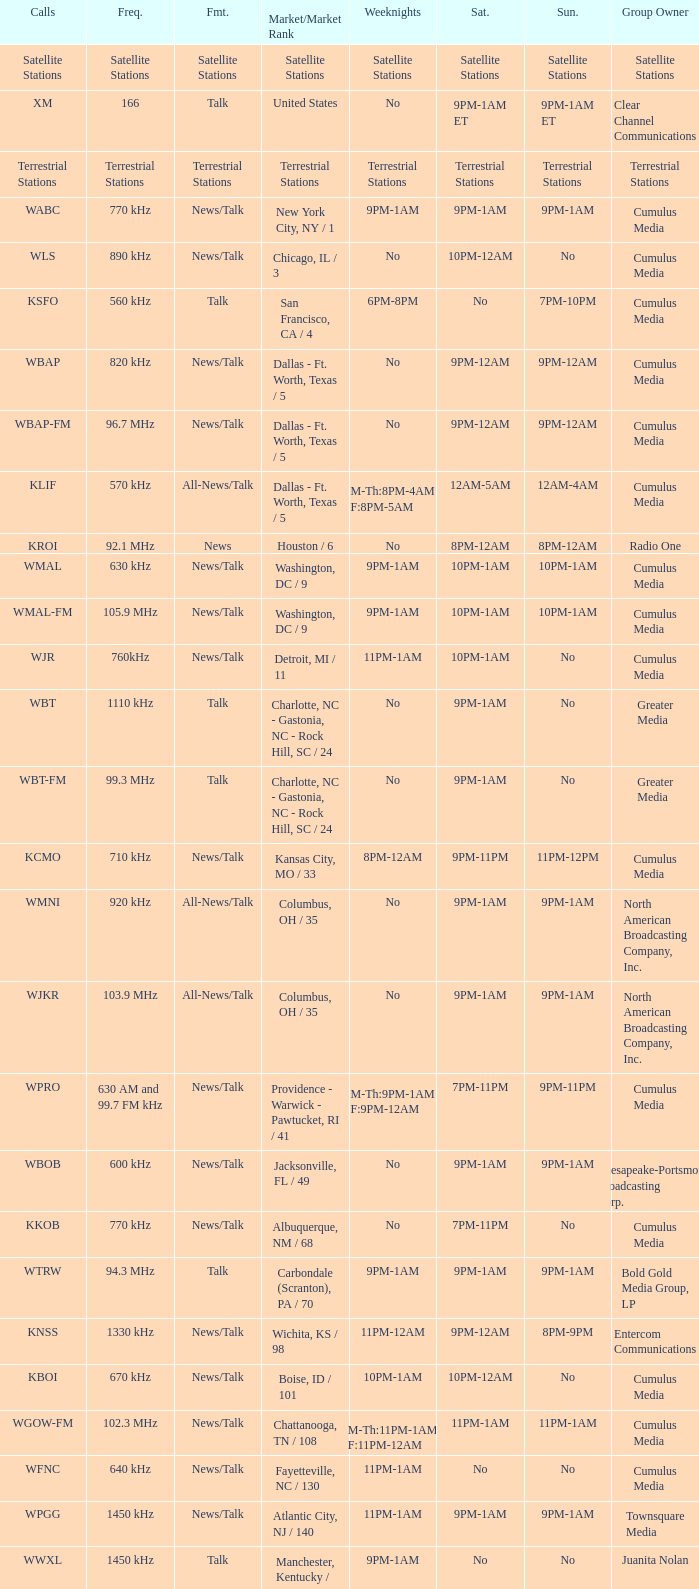What is the market for the 11pm-1am Saturday game? Chattanooga, TN / 108. Write the full table. {'header': ['Calls', 'Freq.', 'Fmt.', 'Market/Market Rank', 'Weeknights', 'Sat.', 'Sun.', 'Group Owner'], 'rows': [['Satellite Stations', 'Satellite Stations', 'Satellite Stations', 'Satellite Stations', 'Satellite Stations', 'Satellite Stations', 'Satellite Stations', 'Satellite Stations'], ['XM', '166', 'Talk', 'United States', 'No', '9PM-1AM ET', '9PM-1AM ET', 'Clear Channel Communications'], ['Terrestrial Stations', 'Terrestrial Stations', 'Terrestrial Stations', 'Terrestrial Stations', 'Terrestrial Stations', 'Terrestrial Stations', 'Terrestrial Stations', 'Terrestrial Stations'], ['WABC', '770 kHz', 'News/Talk', 'New York City, NY / 1', '9PM-1AM', '9PM-1AM', '9PM-1AM', 'Cumulus Media'], ['WLS', '890 kHz', 'News/Talk', 'Chicago, IL / 3', 'No', '10PM-12AM', 'No', 'Cumulus Media'], ['KSFO', '560 kHz', 'Talk', 'San Francisco, CA / 4', '6PM-8PM', 'No', '7PM-10PM', 'Cumulus Media'], ['WBAP', '820 kHz', 'News/Talk', 'Dallas - Ft. Worth, Texas / 5', 'No', '9PM-12AM', '9PM-12AM', 'Cumulus Media'], ['WBAP-FM', '96.7 MHz', 'News/Talk', 'Dallas - Ft. Worth, Texas / 5', 'No', '9PM-12AM', '9PM-12AM', 'Cumulus Media'], ['KLIF', '570 kHz', 'All-News/Talk', 'Dallas - Ft. Worth, Texas / 5', 'M-Th:8PM-4AM F:8PM-5AM', '12AM-5AM', '12AM-4AM', 'Cumulus Media'], ['KROI', '92.1 MHz', 'News', 'Houston / 6', 'No', '8PM-12AM', '8PM-12AM', 'Radio One'], ['WMAL', '630 kHz', 'News/Talk', 'Washington, DC / 9', '9PM-1AM', '10PM-1AM', '10PM-1AM', 'Cumulus Media'], ['WMAL-FM', '105.9 MHz', 'News/Talk', 'Washington, DC / 9', '9PM-1AM', '10PM-1AM', '10PM-1AM', 'Cumulus Media'], ['WJR', '760kHz', 'News/Talk', 'Detroit, MI / 11', '11PM-1AM', '10PM-1AM', 'No', 'Cumulus Media'], ['WBT', '1110 kHz', 'Talk', 'Charlotte, NC - Gastonia, NC - Rock Hill, SC / 24', 'No', '9PM-1AM', 'No', 'Greater Media'], ['WBT-FM', '99.3 MHz', 'Talk', 'Charlotte, NC - Gastonia, NC - Rock Hill, SC / 24', 'No', '9PM-1AM', 'No', 'Greater Media'], ['KCMO', '710 kHz', 'News/Talk', 'Kansas City, MO / 33', '8PM-12AM', '9PM-11PM', '11PM-12PM', 'Cumulus Media'], ['WMNI', '920 kHz', 'All-News/Talk', 'Columbus, OH / 35', 'No', '9PM-1AM', '9PM-1AM', 'North American Broadcasting Company, Inc.'], ['WJKR', '103.9 MHz', 'All-News/Talk', 'Columbus, OH / 35', 'No', '9PM-1AM', '9PM-1AM', 'North American Broadcasting Company, Inc.'], ['WPRO', '630 AM and 99.7 FM kHz', 'News/Talk', 'Providence - Warwick - Pawtucket, RI / 41', 'M-Th:9PM-1AM F:9PM-12AM', '7PM-11PM', '9PM-11PM', 'Cumulus Media'], ['WBOB', '600 kHz', 'News/Talk', 'Jacksonville, FL / 49', 'No', '9PM-1AM', '9PM-1AM', 'Chesapeake-Portsmouth Broadcasting Corp.'], ['KKOB', '770 kHz', 'News/Talk', 'Albuquerque, NM / 68', 'No', '7PM-11PM', 'No', 'Cumulus Media'], ['WTRW', '94.3 MHz', 'Talk', 'Carbondale (Scranton), PA / 70', '9PM-1AM', '9PM-1AM', '9PM-1AM', 'Bold Gold Media Group, LP'], ['KNSS', '1330 kHz', 'News/Talk', 'Wichita, KS / 98', '11PM-12AM', '9PM-12AM', '8PM-9PM', 'Entercom Communications'], ['KBOI', '670 kHz', 'News/Talk', 'Boise, ID / 101', '10PM-1AM', '10PM-12AM', 'No', 'Cumulus Media'], ['WGOW-FM', '102.3 MHz', 'News/Talk', 'Chattanooga, TN / 108', 'M-Th:11PM-1AM F:11PM-12AM', '11PM-1AM', '11PM-1AM', 'Cumulus Media'], ['WFNC', '640 kHz', 'News/Talk', 'Fayetteville, NC / 130', '11PM-1AM', 'No', 'No', 'Cumulus Media'], ['WPGG', '1450 kHz', 'News/Talk', 'Atlantic City, NJ / 140', '11PM-1AM', '9PM-1AM', '9PM-1AM', 'Townsquare Media'], ['WWXL', '1450 kHz', 'Talk', 'Manchester, Kentucky / NA', '9PM-1AM', 'No', 'No', 'Juanita Nolan'], ['WXLM', '980 kHz', 'News/Talk', 'New London, CT / 176', '9PM-1AM', 'No', 'No', 'Cumulus Media'], ['WKMI', '1360 kHz', 'News/Talk', 'Kalamazoo, MI / 183', '9PM-1AM', 'No', 'No', 'Cumulus Media'], ['KSLI', '1280 kHz', 'News/Talk', 'Abilene, TX / 245', '8PM-12AM', 'No', 'No', 'GAP Broadcasting'], ['KXL-FM', '101.1 MHz', 'News/Talk', 'Portland, OR / NA', 'No', 'No', '1AM-5AM', 'Alpha Broadcasting']]} 